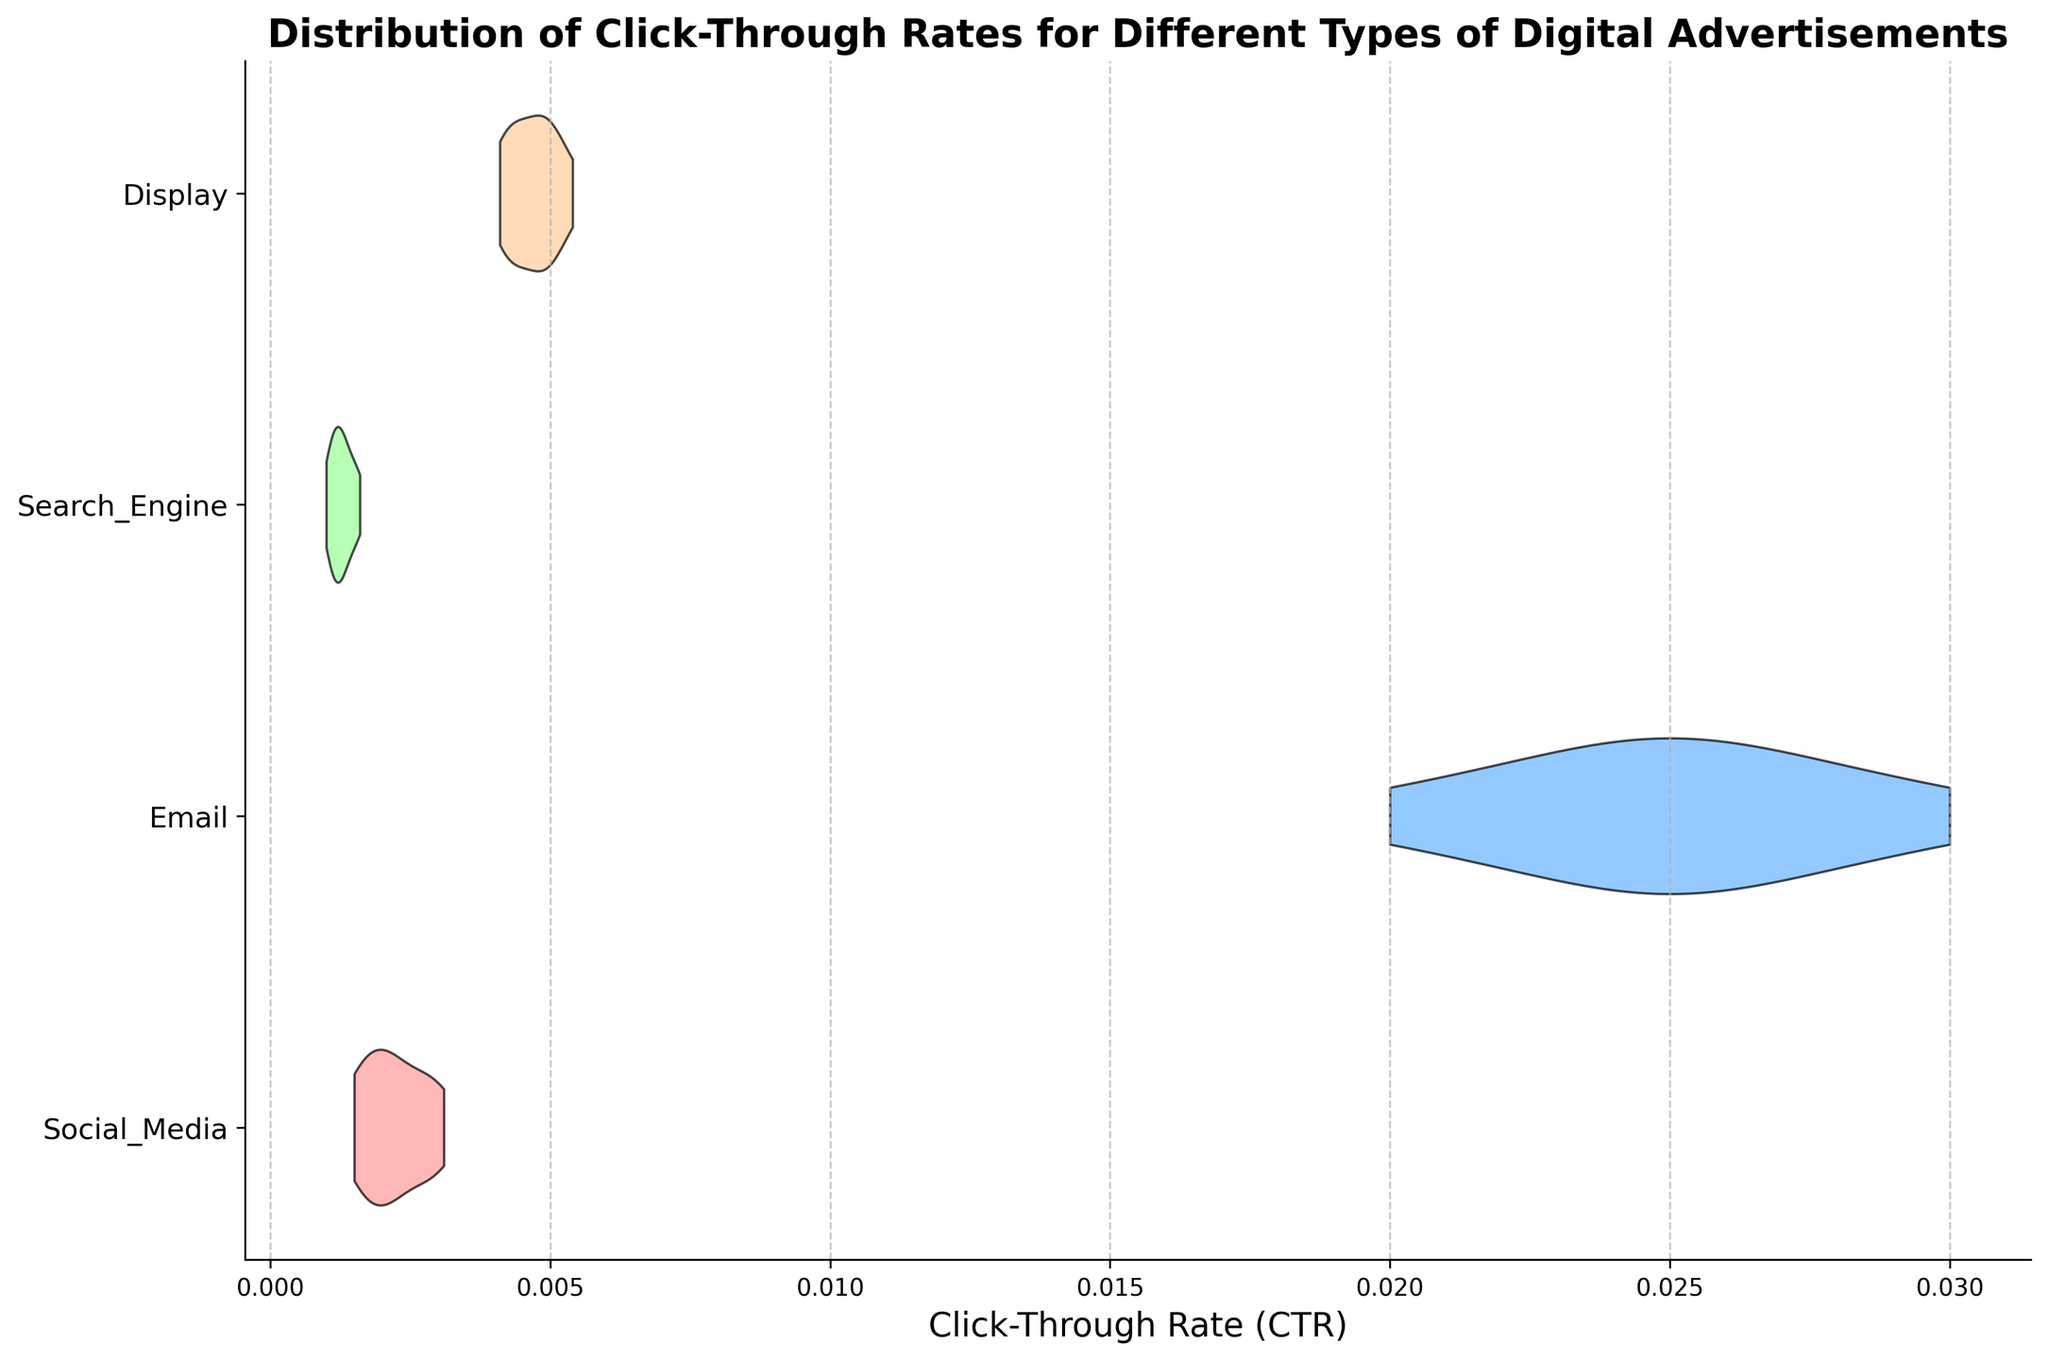What are the types of digital advertisements shown in the figure? The title of the figure indicates it's about click-through rates for different digital advertisements, and the y-axis labels show four types: Social Media, Email, Search Engine, and Display.
Answer: Social Media, Email, Search Engine, Display Which advertisement type has the highest median click-through rate? The shape and width of the violin plots at different points represent the density of data points. The Email advertisement has its peak density center higher than other types.
Answer: Email What is the range of click-through rates for Display advertisements? The plot for Display advertisement has a spread from the leftmost to the rightmost point on the x-axis. This range appears to be from just above 0.004 to just above 0.005.
Answer: 0.0041 to 0.0054 How does the density of click-through rates for Social Media compare to Search Engine? Compare the width of the violin plots: Social Media's plot is wider at higher CTRs, indicating more data points in that range, whereas Search Engine's plot density appears consistently low and centered around lower CTRs than Social Media.
Answer: Social Media has higher density at higher CTRs compared to Search Engine Which digital advertisement type has the smallest variation in click-through rates? Looking at the width and spread of the violin plots, the Search Engine advertisement type has the narrowest and most centered distribution, indicating smaller variation.
Answer: Search Engine Is the average click-through rate for Email higher than for Display? Both halves of the Email's plot show higher density at higher CTRs compared to Display, which indicates that on average, Email has a higher click-through rate.
Answer: Yes Describe the overall shape and spread of the Social Media advertisement type. The Social Media plot is slightly wide and spread between 0.0015 and 0.0031, with more density towards the central value around 0.0020-0.0027.
Answer: Wide spread, dense around 0.0020-0.0027 Between Social Media and Display, which type shows greater symmetry in click-through rate distribution? Display's violin plot looks more symmetrical around its center, whereas Social Media's plot is slightly skewed with more density towards higher CTR values.
Answer: Display 